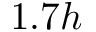Convert formula to latex. <formula><loc_0><loc_0><loc_500><loc_500>1 . 7 h</formula> 